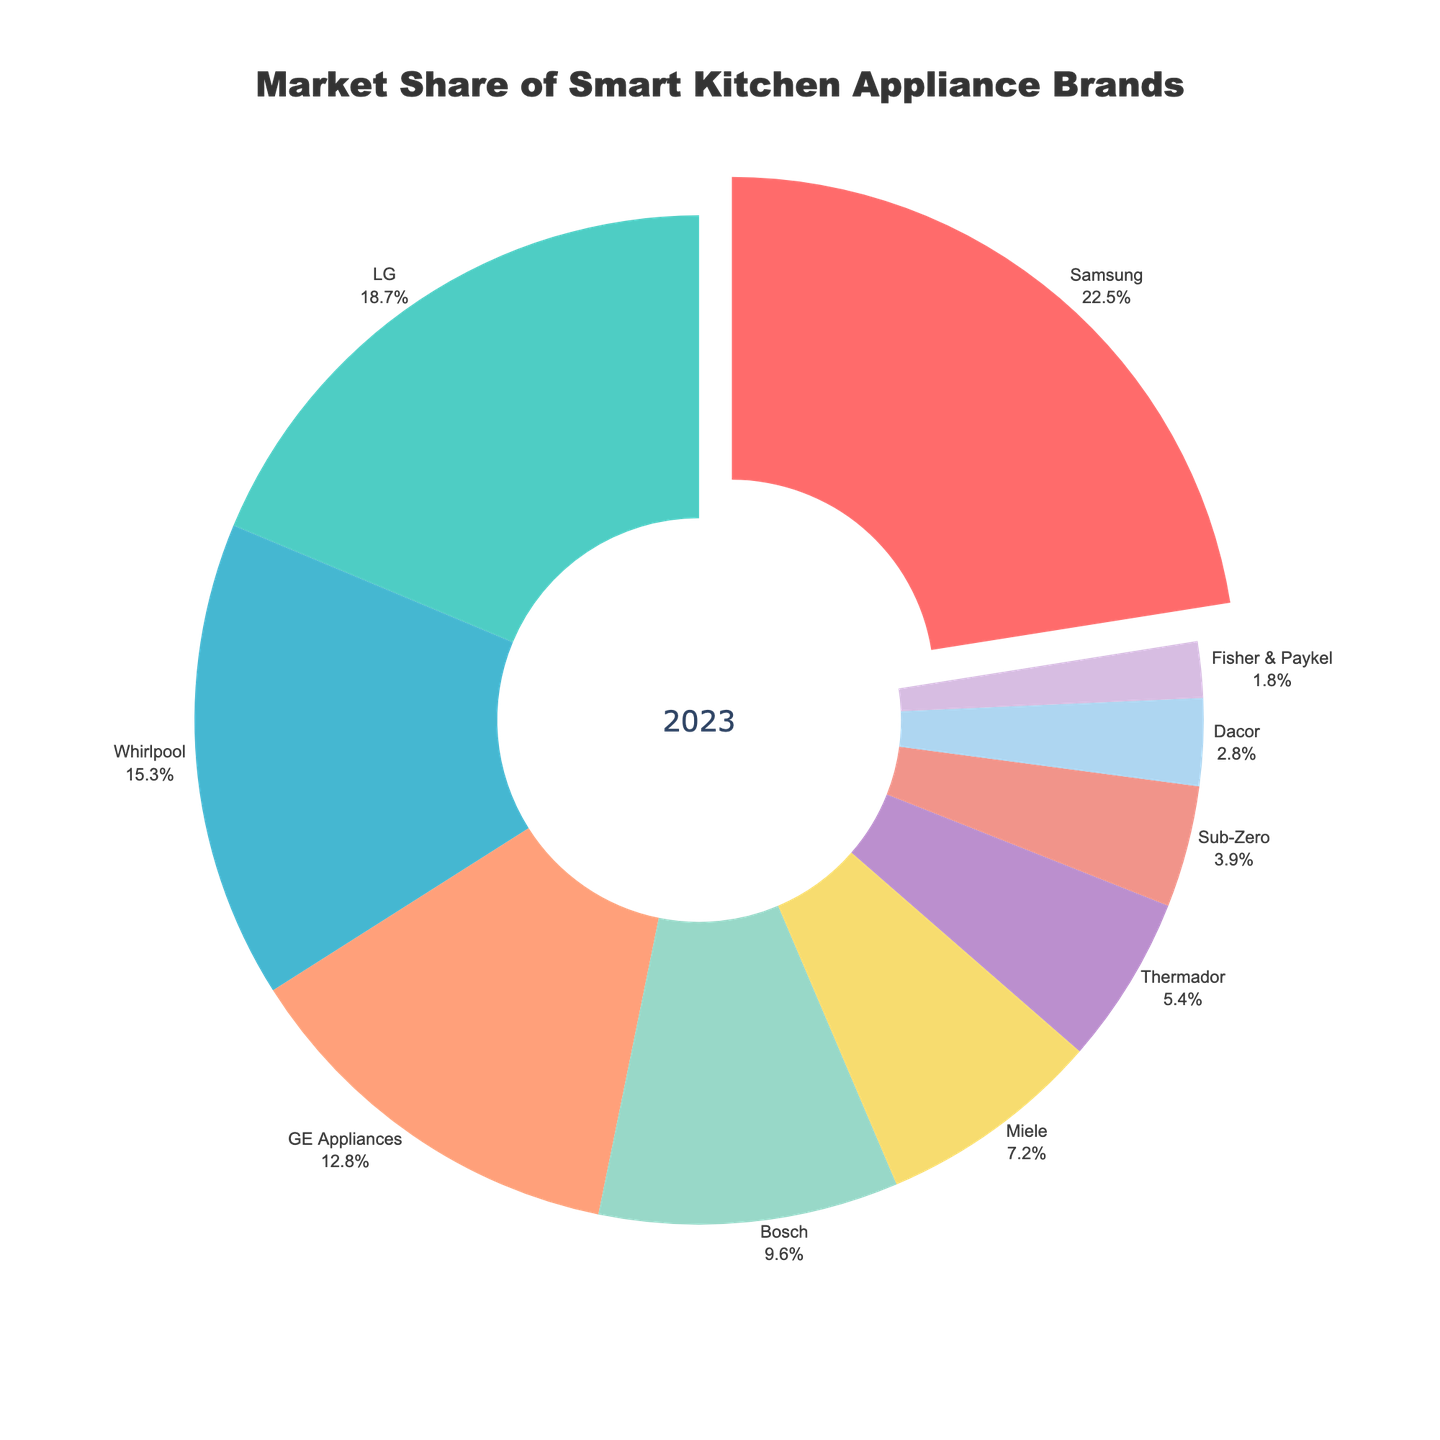what's the total market share of the top three brands? Add the market shares of Samsung (22.5), LG (18.7), and Whirlpool (15.3). 22.5 + 18.7 + 15.3 = 56.5.
Answer: 56.5 Which brand has the smallest market share? Identify the brand with the lowest value. Fisher & Paykel has the smallest share at 1.8%.
Answer: Fisher & Paykel How much larger is Samsung's market share compared to GE Appliances? Subtract the market share of GE Appliances (12.8) from Samsung's (22.5). 22.5 - 12.8 = 9.7.
Answer: 9.7 Which brands collectively share more than 50% of the market? Sum the market shares progressively until the total exceeds 50%. Samsung (22.5) + LG (18.7) + Whirlpool (15.3) = 56.5. The top three brands collectively share more than 50%.
Answer: Samsung, LG, Whirlpool What's the combined market share of Bosch, Miele, and Thermador? Add the market shares of Bosch (9.6), Miele (7.2), and Thermador (5.4). 9.6 + 7.2 + 5.4 = 22.2.
Answer: 22.2 Which brand represents approximately one-fifth of the market? Determine which market share is close to 20%. Samsung, with a 22.5% market share, is approximately one-fifth of the market.
Answer: Samsung What visual feature emphasizes Samsung in the chart? Identify the unique visual attribute applied to Samsung. Samsung's slice is pulled out from the pie, distinct from others.
Answer: Pulled out slice Which brand's slice is colored green? Identify the color used for each brand's market share slice. LG's slice is green.
Answer: LG What is the market share difference between the largest and smallest brands? Subtract the market share of Fisher & Paykel (1.8) from Samsung's (22.5). 22.5 - 1.8 = 20.7.
Answer: 20.7 How many brands have a market share under 10%? Count the brands with market shares less than 10%. Bosch, Miele, Thermador, Sub-Zero, Dacor, and Fisher & Paykel all have under 10%. This totals six brands.
Answer: 6 